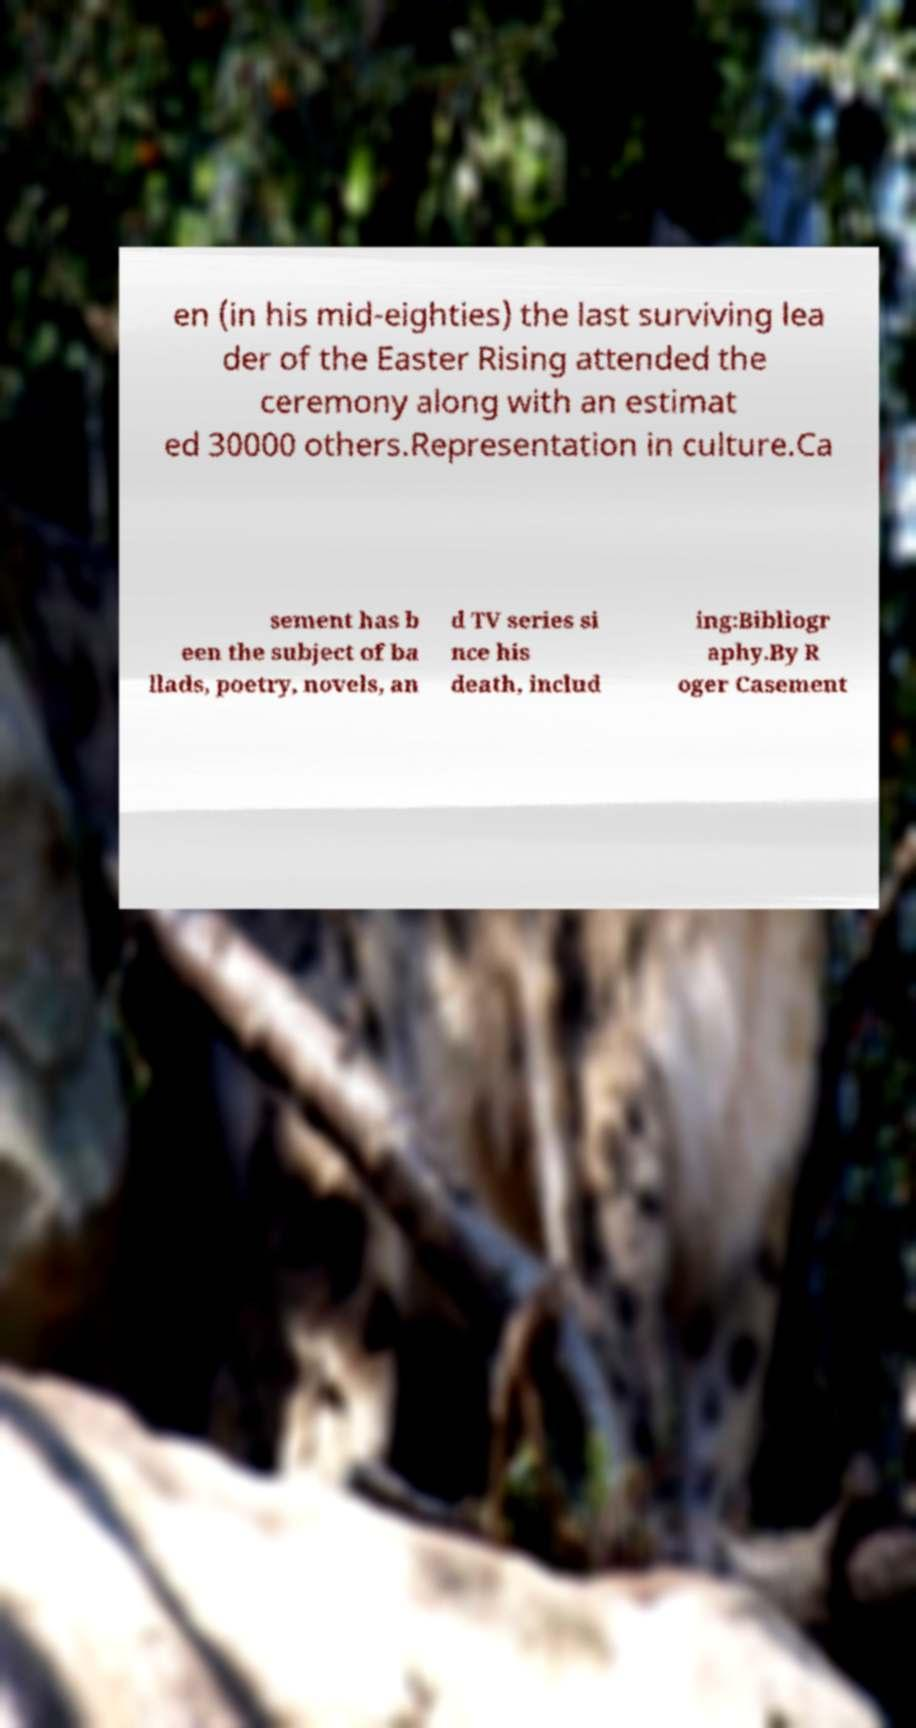I need the written content from this picture converted into text. Can you do that? en (in his mid-eighties) the last surviving lea der of the Easter Rising attended the ceremony along with an estimat ed 30000 others.Representation in culture.Ca sement has b een the subject of ba llads, poetry, novels, an d TV series si nce his death, includ ing:Bibliogr aphy.By R oger Casement 